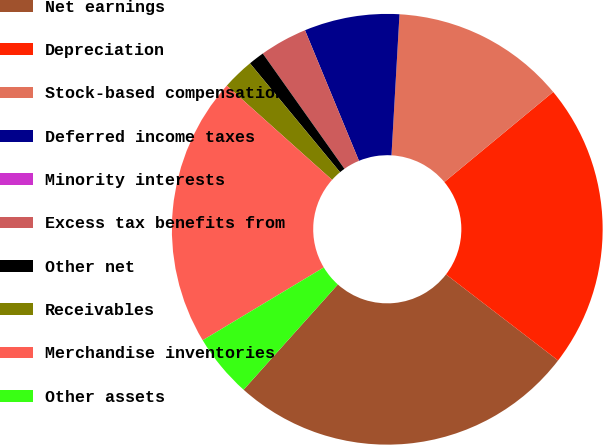Convert chart. <chart><loc_0><loc_0><loc_500><loc_500><pie_chart><fcel>Net earnings<fcel>Depreciation<fcel>Stock-based compensation<fcel>Deferred income taxes<fcel>Minority interests<fcel>Excess tax benefits from<fcel>Other net<fcel>Receivables<fcel>Merchandise inventories<fcel>Other assets<nl><fcel>26.19%<fcel>21.42%<fcel>13.09%<fcel>7.14%<fcel>0.0%<fcel>3.57%<fcel>1.19%<fcel>2.38%<fcel>20.23%<fcel>4.76%<nl></chart> 